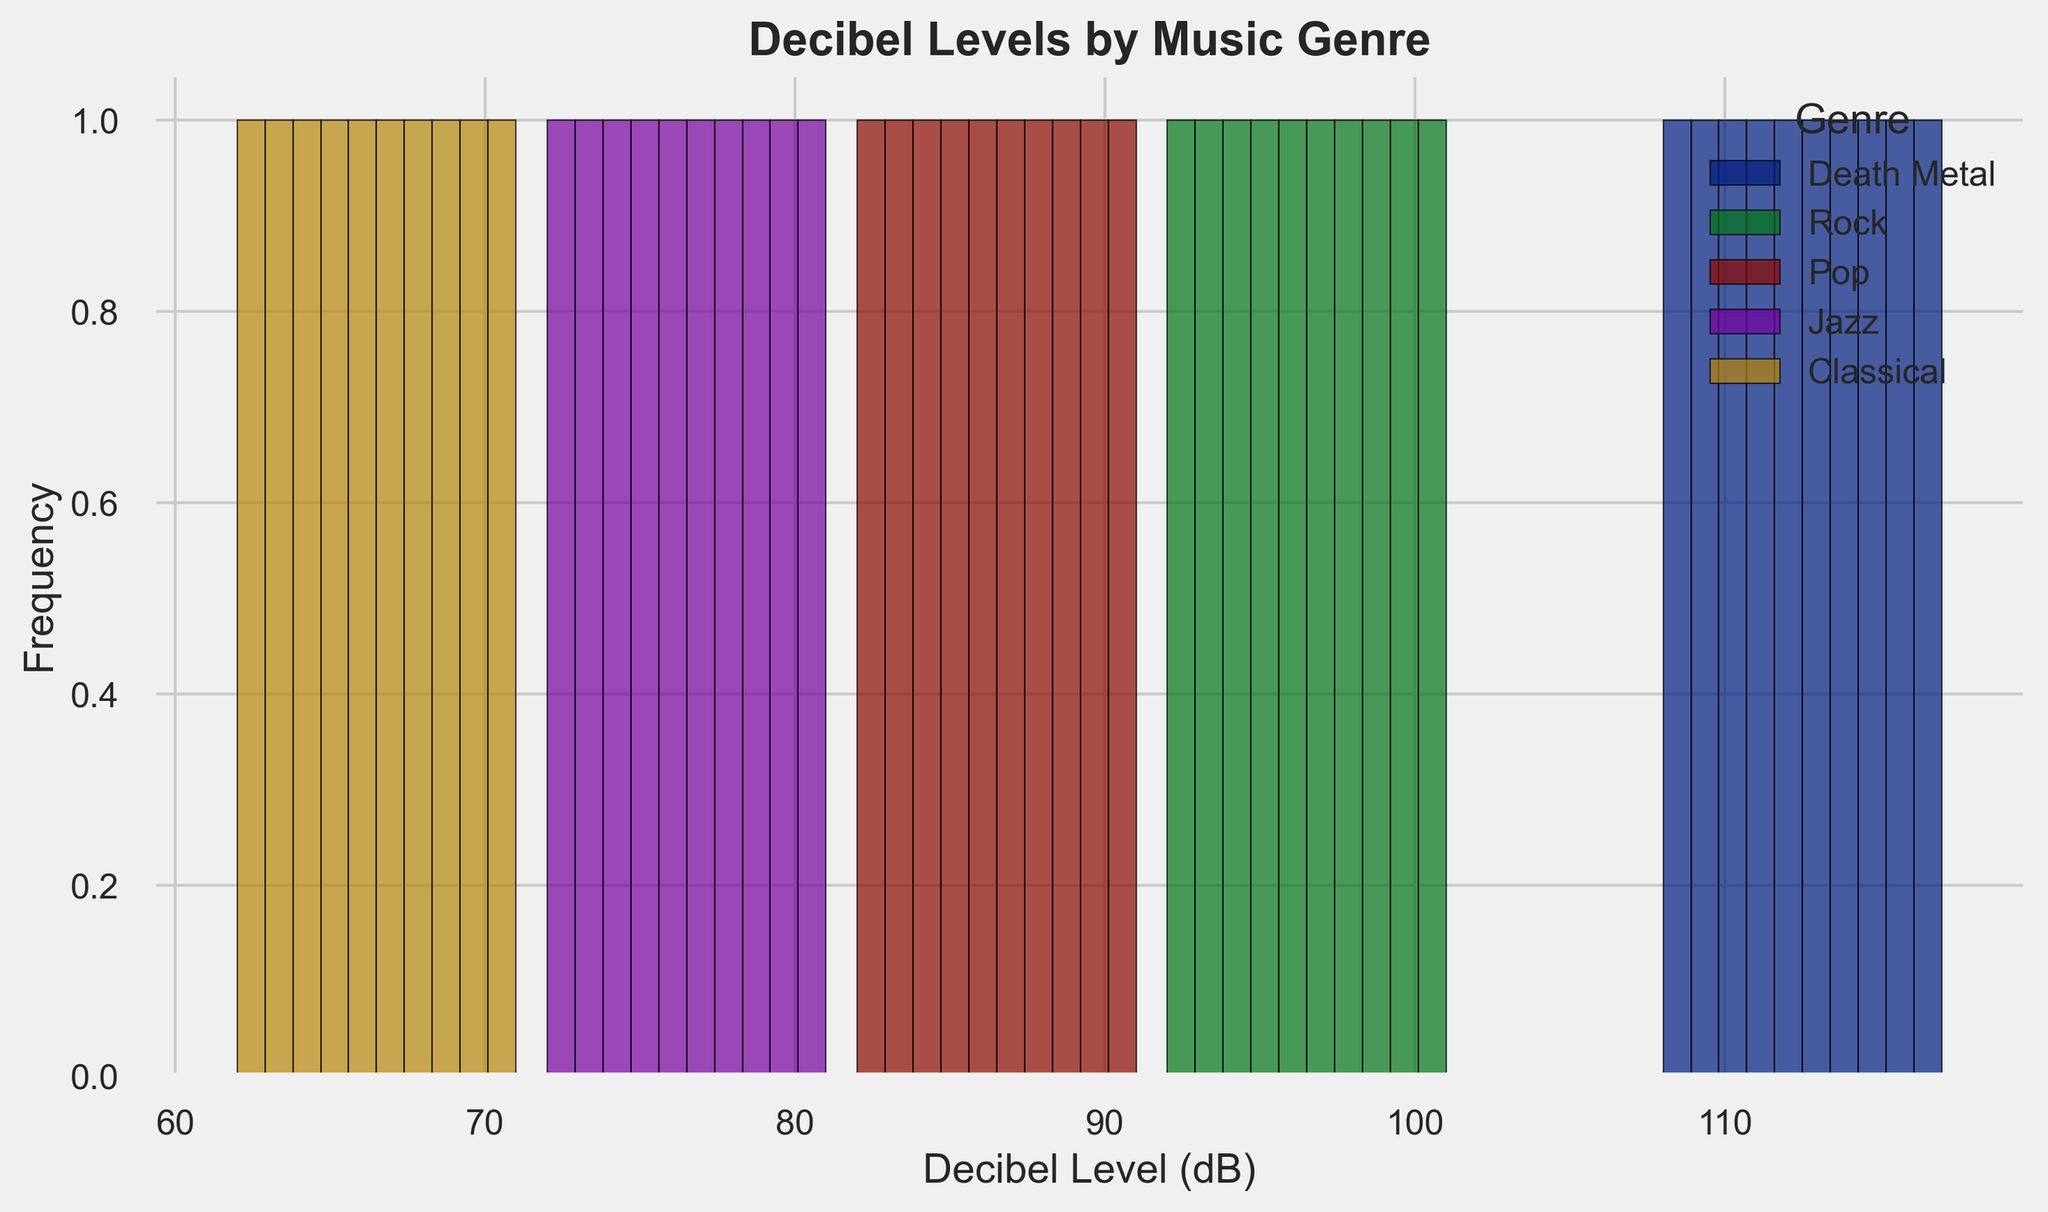How many genres are represented in the histogram? By counting the unique labels in the legend or the unique colored bars within the histogram, we see there are five genres displayed: Death Metal, Rock, Pop, Jazz, and Classical. So, there are 5 genres in the histogram.
Answer: 5 genres Which genre has the highest average decibel level? By comparing the positions of the bars along the x-axis for each genre, the Death Metal genre has its bars clustered around higher decibel values compared to other genres.
Answer: Death Metal What is the decibel range covered by the Death Metal genre? Looking at the distribution of the Death Metal bars, they range approximately from 108 to 117 decibels. Subtracting the minimum from the maximum gives the range.
Answer: 9 dB Which genre is generally louder, Rock or Pop? By comparing the overlap and position of the bars of Rock and Pop on the x-axis, it is evident that Rock's bars are shifted towards higher decibel levels compared to Pop.
Answer: Rock What is the most frequent decibel level range for Classical music in the histogram? Observing the histogram for the Classical genre, most bars fall between 62 and 71 decibels. This implies that the most common range is 62-71 dB.
Answer: 62-71 dB How many different decibel bins are there for Jazz? By counting the distinct bars representing Jazz, the Jazz genre is divided into bins of approximately equal width on the x-axis, from 72 to 81 dB. There are roughly 10 bins.
Answer: 10 bins Which genre shows more variability, Death Metal or Classical? By observing the spread of the bars, Death Metal has its bars spread over the range of 108-117 dB, while Classical’s bars spread over 62-71 dB. Death Metal shows more variability as its range is broader.
Answer: Death Metal Is Pop music typically louder than Jazz music? By comparing their respective bar distributions, Pop music has decibel values ranging from roughly 82-91 dB, whereas Jazz ranges from 72-81 dB. Hence, Pop is typically louder than Jazz.
Answer: Yes What can be said about the frequency of decibel levels for Death Metal compared to Jazz? The height of the bars for Death Metal is generally higher than for Jazz, indicating a higher frequency of concert decibel levels within its range than Jazz.
Answer: Death Metal has higher frequency decibel levels Which genre overlaps the least with Death Metal on the decibel scale? By examining the position of the bars along the x-axis, Classical music, with decibel levels ranging from 62 to 71 dB, has the least overlap with Death Metal’s 108-117 dB range.
Answer: Classical 